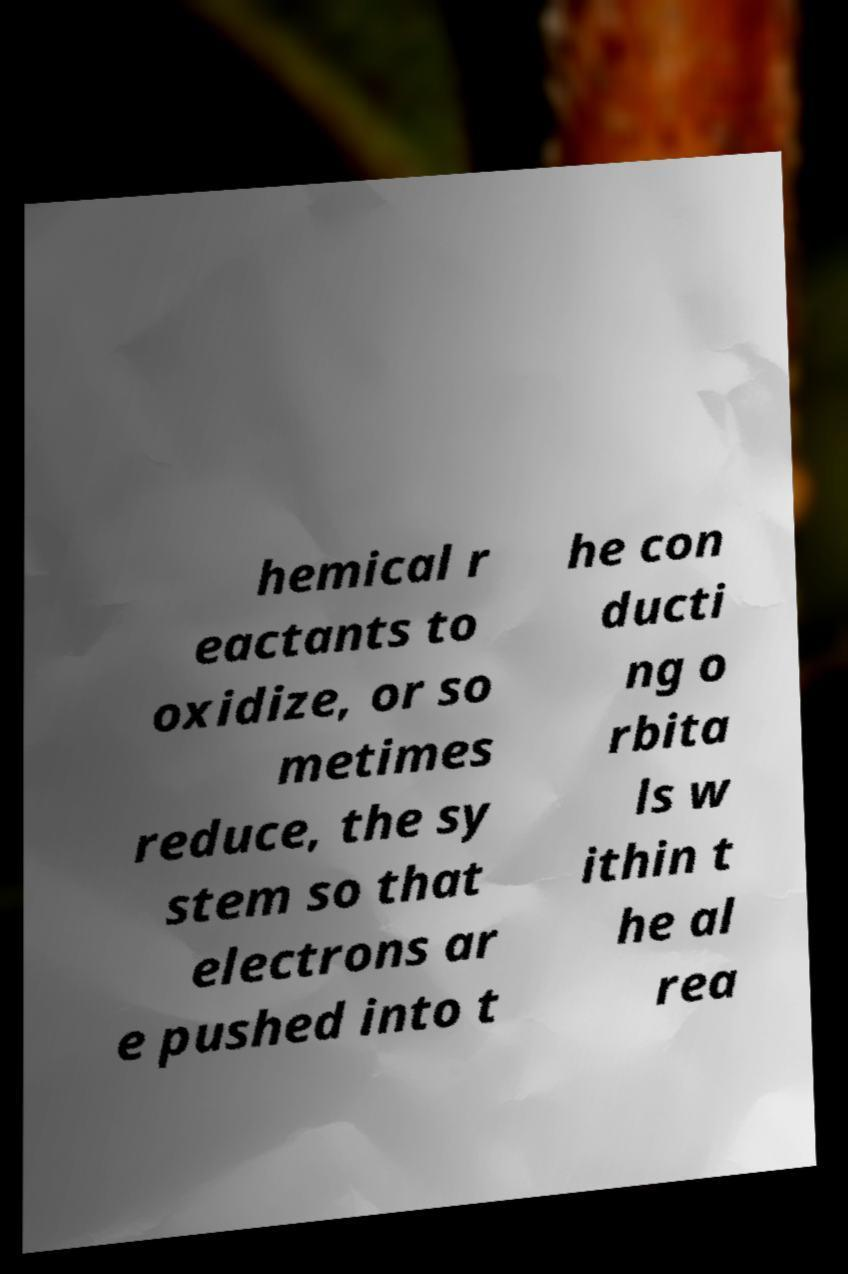Can you read and provide the text displayed in the image?This photo seems to have some interesting text. Can you extract and type it out for me? hemical r eactants to oxidize, or so metimes reduce, the sy stem so that electrons ar e pushed into t he con ducti ng o rbita ls w ithin t he al rea 